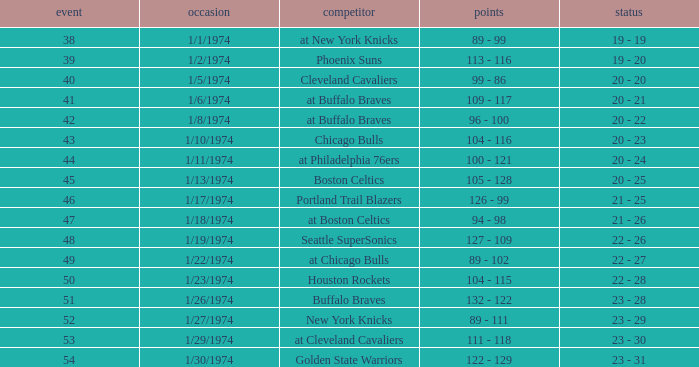What opponent played on 1/13/1974? Boston Celtics. Help me parse the entirety of this table. {'header': ['event', 'occasion', 'competitor', 'points', 'status'], 'rows': [['38', '1/1/1974', 'at New York Knicks', '89 - 99', '19 - 19'], ['39', '1/2/1974', 'Phoenix Suns', '113 - 116', '19 - 20'], ['40', '1/5/1974', 'Cleveland Cavaliers', '99 - 86', '20 - 20'], ['41', '1/6/1974', 'at Buffalo Braves', '109 - 117', '20 - 21'], ['42', '1/8/1974', 'at Buffalo Braves', '96 - 100', '20 - 22'], ['43', '1/10/1974', 'Chicago Bulls', '104 - 116', '20 - 23'], ['44', '1/11/1974', 'at Philadelphia 76ers', '100 - 121', '20 - 24'], ['45', '1/13/1974', 'Boston Celtics', '105 - 128', '20 - 25'], ['46', '1/17/1974', 'Portland Trail Blazers', '126 - 99', '21 - 25'], ['47', '1/18/1974', 'at Boston Celtics', '94 - 98', '21 - 26'], ['48', '1/19/1974', 'Seattle SuperSonics', '127 - 109', '22 - 26'], ['49', '1/22/1974', 'at Chicago Bulls', '89 - 102', '22 - 27'], ['50', '1/23/1974', 'Houston Rockets', '104 - 115', '22 - 28'], ['51', '1/26/1974', 'Buffalo Braves', '132 - 122', '23 - 28'], ['52', '1/27/1974', 'New York Knicks', '89 - 111', '23 - 29'], ['53', '1/29/1974', 'at Cleveland Cavaliers', '111 - 118', '23 - 30'], ['54', '1/30/1974', 'Golden State Warriors', '122 - 129', '23 - 31']]} 